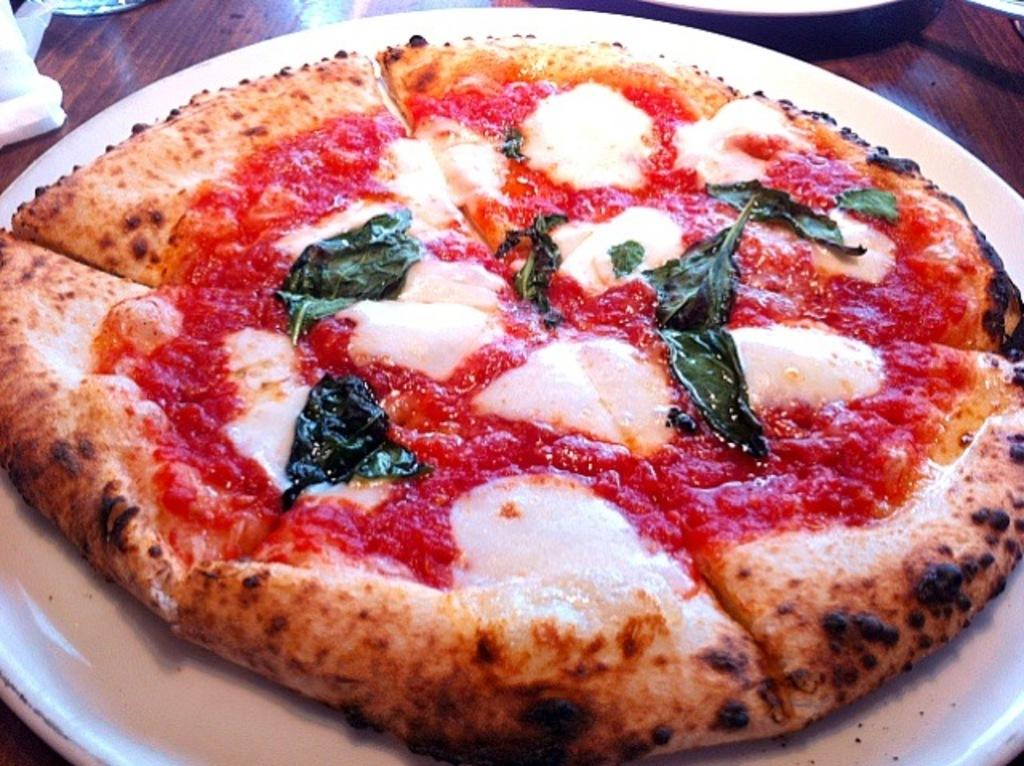What type of food is shown in the image? There is a pizza in the image. What is the main ingredient on the pizza? The pizza is garnished with tomato sauce. Are there any additional toppings on the pizza? Yes, the pizza has coriander leaves on it. Where is the pizza placed in the image? The pizza is on a plate. What surface is the plate resting on? The plate is on a table. What color is the underwear worn by the person in the image? There is no person or underwear present in the image; it features a pizza on a plate. What type of wish can be granted by the pizza in the image? There is no wish-granting ability associated with the pizza in the image; it is simply a food item. 